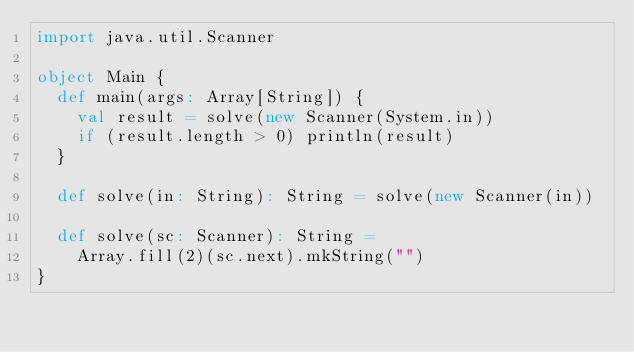Convert code to text. <code><loc_0><loc_0><loc_500><loc_500><_Scala_>import java.util.Scanner

object Main {
  def main(args: Array[String]) {
    val result = solve(new Scanner(System.in))
    if (result.length > 0) println(result)
  }

  def solve(in: String): String = solve(new Scanner(in))

  def solve(sc: Scanner): String =
    Array.fill(2)(sc.next).mkString("")
}
</code> 